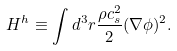Convert formula to latex. <formula><loc_0><loc_0><loc_500><loc_500>H ^ { h } \equiv \int d ^ { 3 } { r } \frac { \rho c _ { s } ^ { 2 } } { 2 } ( \nabla \phi ) ^ { 2 } .</formula> 